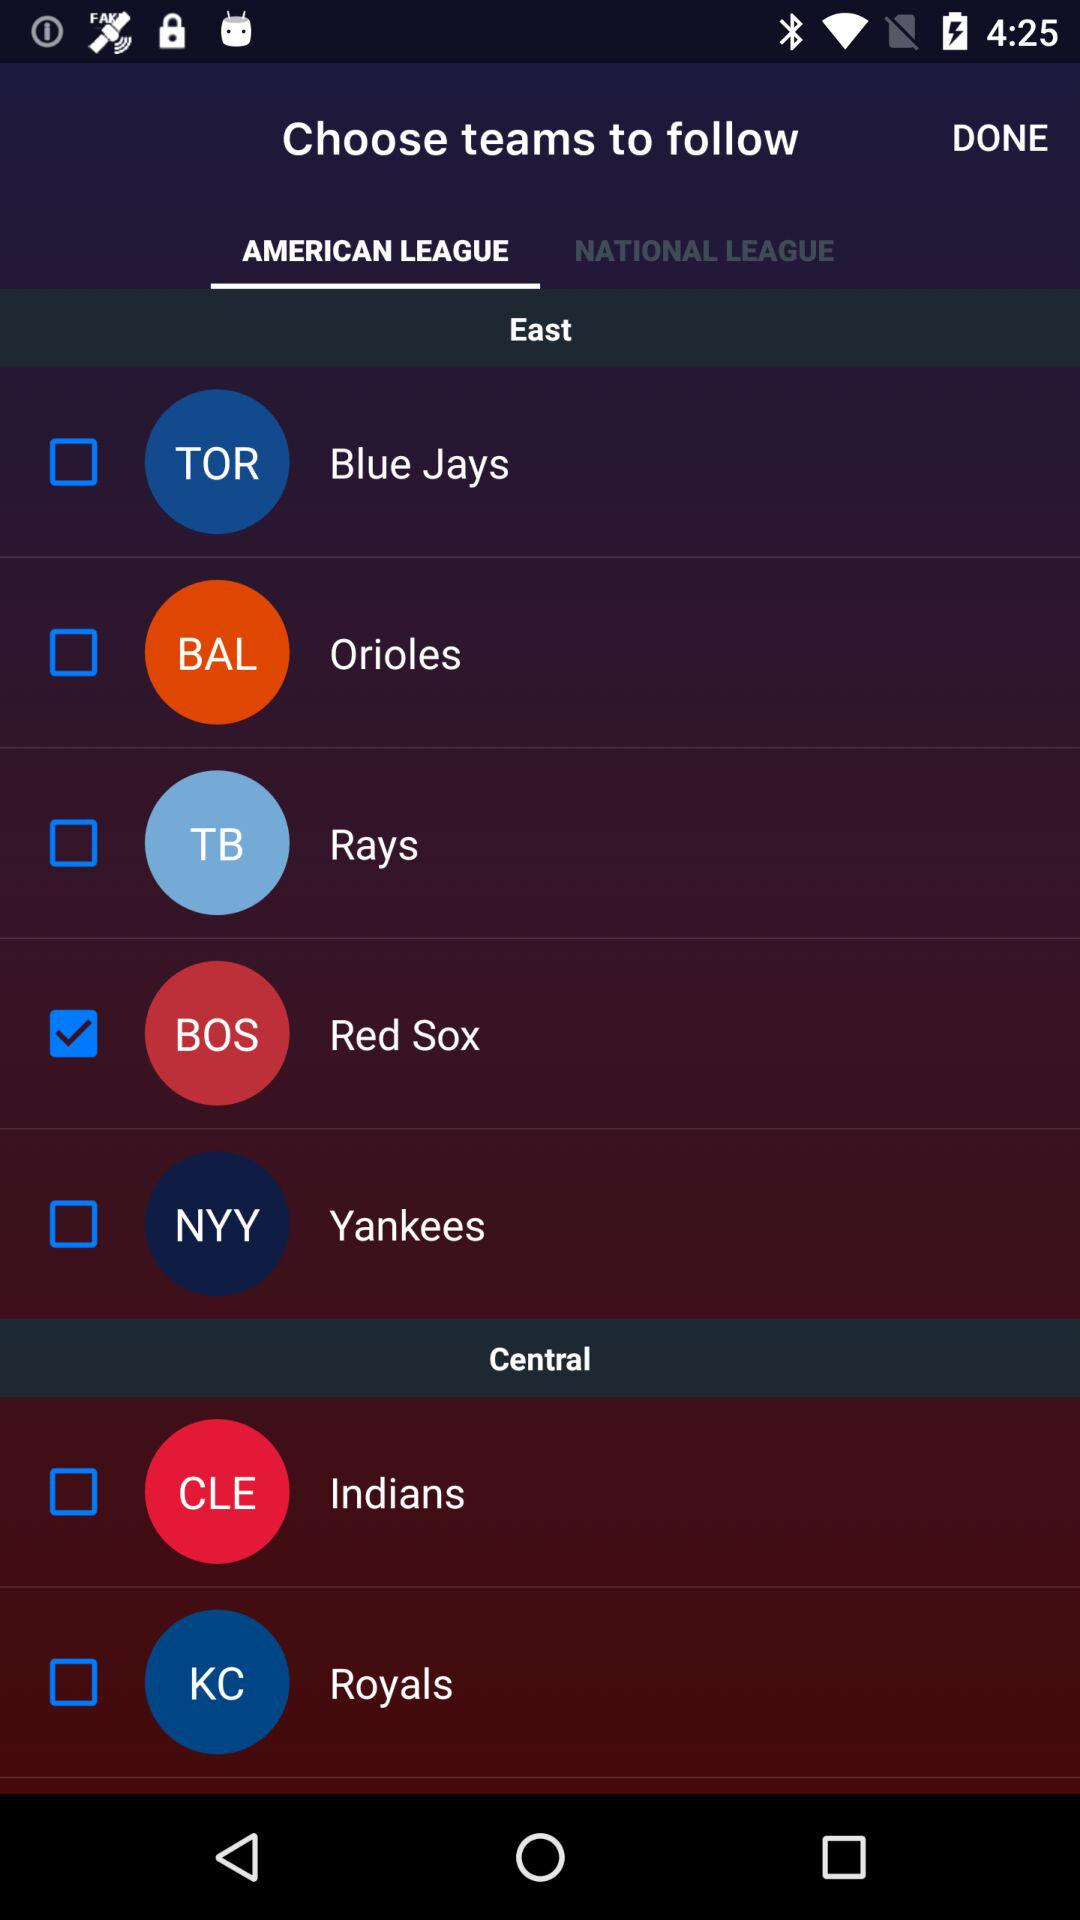Which tab is currently selected? The currently selected tab is "AMERICAN LEAGUE". 